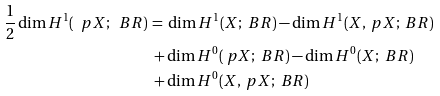<formula> <loc_0><loc_0><loc_500><loc_500>\frac { 1 } { 2 } \dim H ^ { 1 } ( \ p X ; \ B R ) \, & = \, \dim H ^ { 1 } ( X ; \ B R ) - \dim H ^ { 1 } ( X , \ p X ; \ B R ) \\ & \, + \dim H ^ { 0 } ( \ p X ; \ B R ) - \dim H ^ { 0 } ( X ; \ B R ) \\ & \, + \dim H ^ { 0 } ( X , \ p X ; \ B R )</formula> 